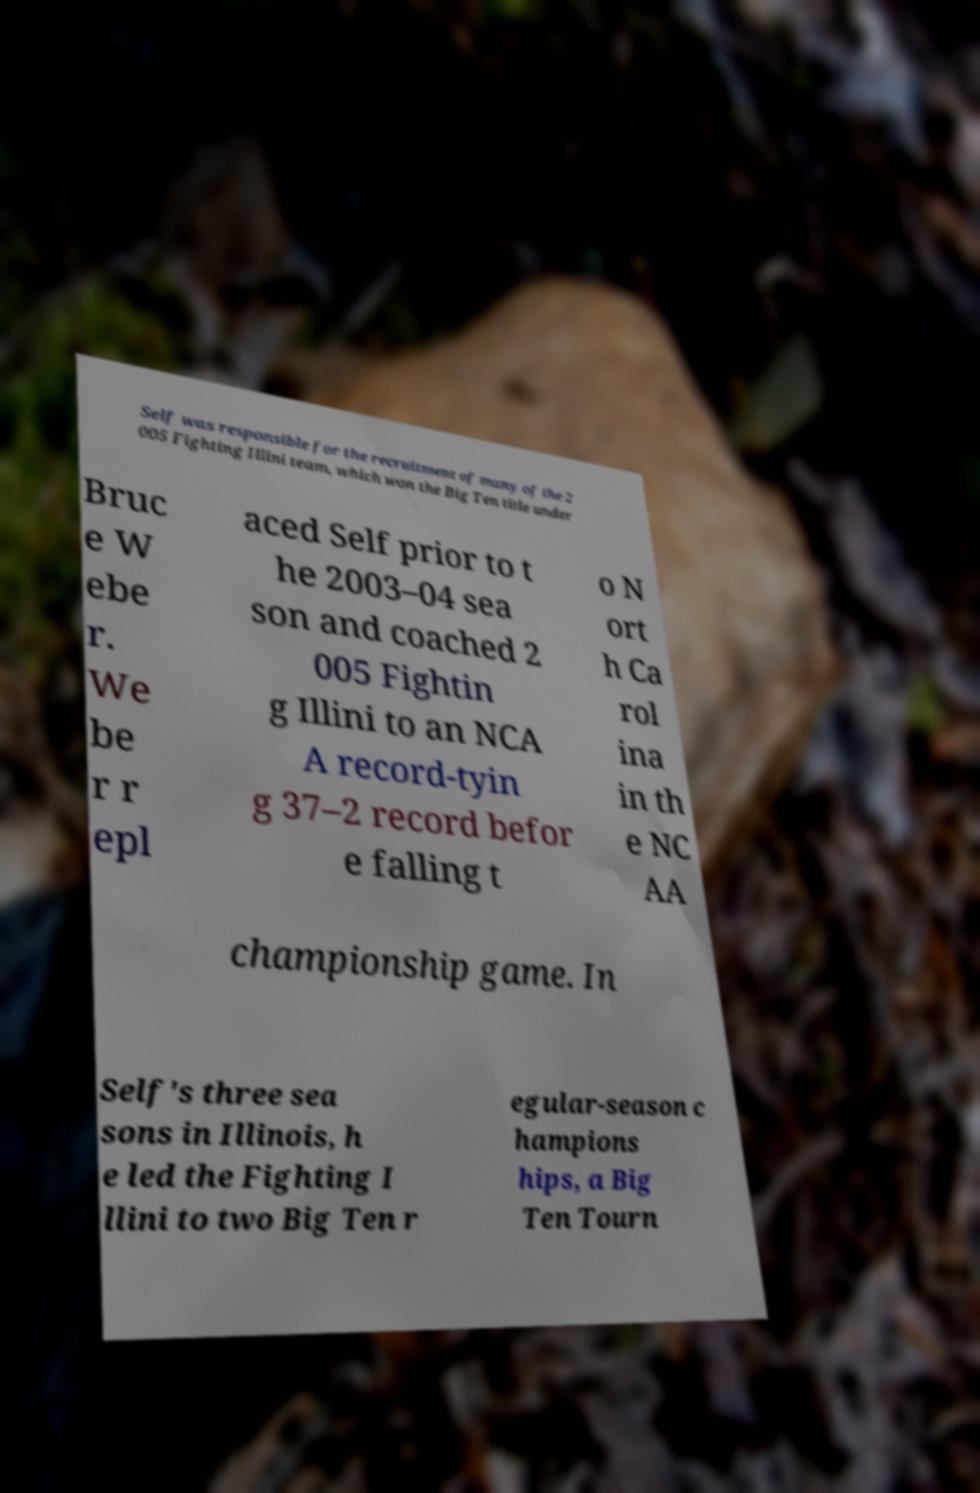Please identify and transcribe the text found in this image. Self was responsible for the recruitment of many of the 2 005 Fighting Illini team, which won the Big Ten title under Bruc e W ebe r. We be r r epl aced Self prior to t he 2003–04 sea son and coached 2 005 Fightin g Illini to an NCA A record-tyin g 37–2 record befor e falling t o N ort h Ca rol ina in th e NC AA championship game. In Self's three sea sons in Illinois, h e led the Fighting I llini to two Big Ten r egular-season c hampions hips, a Big Ten Tourn 